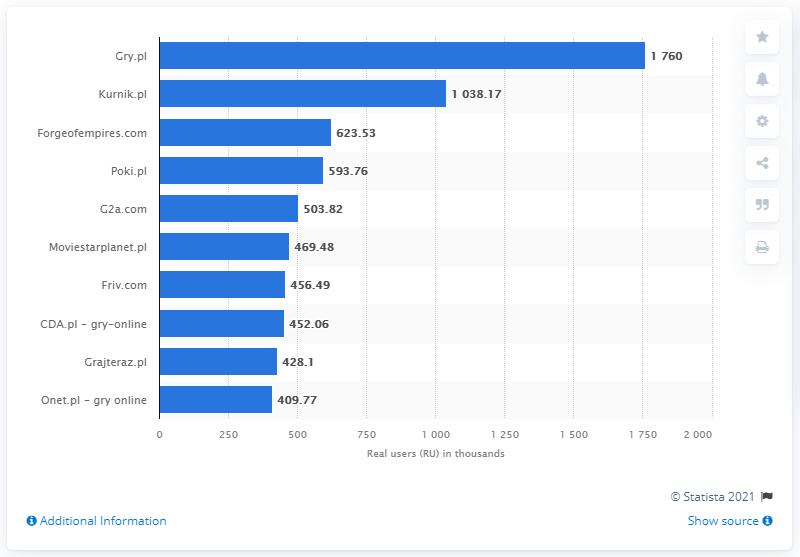Can you tell me more about the types of games that contributed to Gry.pl's success? Gry.pl's success can often be attributed to a wide variety of games they offer, which likely cater to many different gaming preferences. They may include genres such as action, puzzle, sports, and adventure games. Games that are easy to pick up but challenging to master, such as casual and mobile-friendly games, can significantly contribute to the engagement levels seen on the platform. 